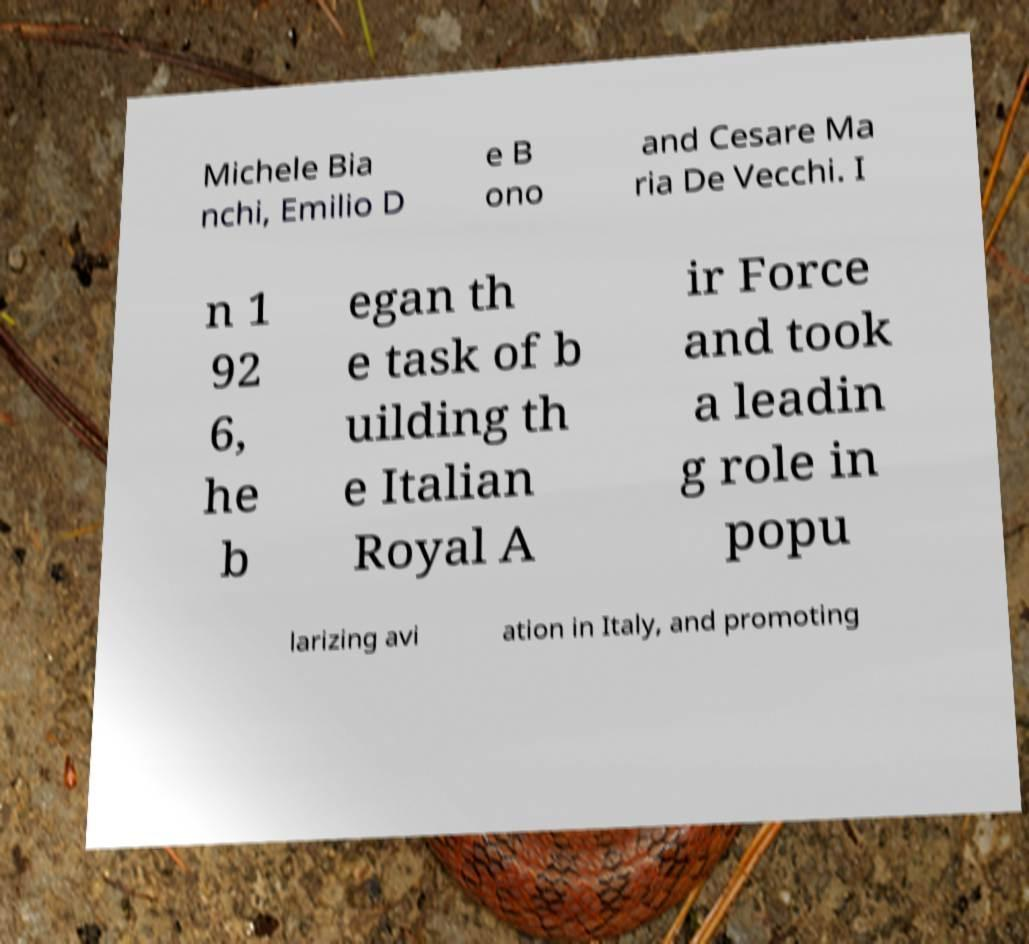I need the written content from this picture converted into text. Can you do that? Michele Bia nchi, Emilio D e B ono and Cesare Ma ria De Vecchi. I n 1 92 6, he b egan th e task of b uilding th e Italian Royal A ir Force and took a leadin g role in popu larizing avi ation in Italy, and promoting 